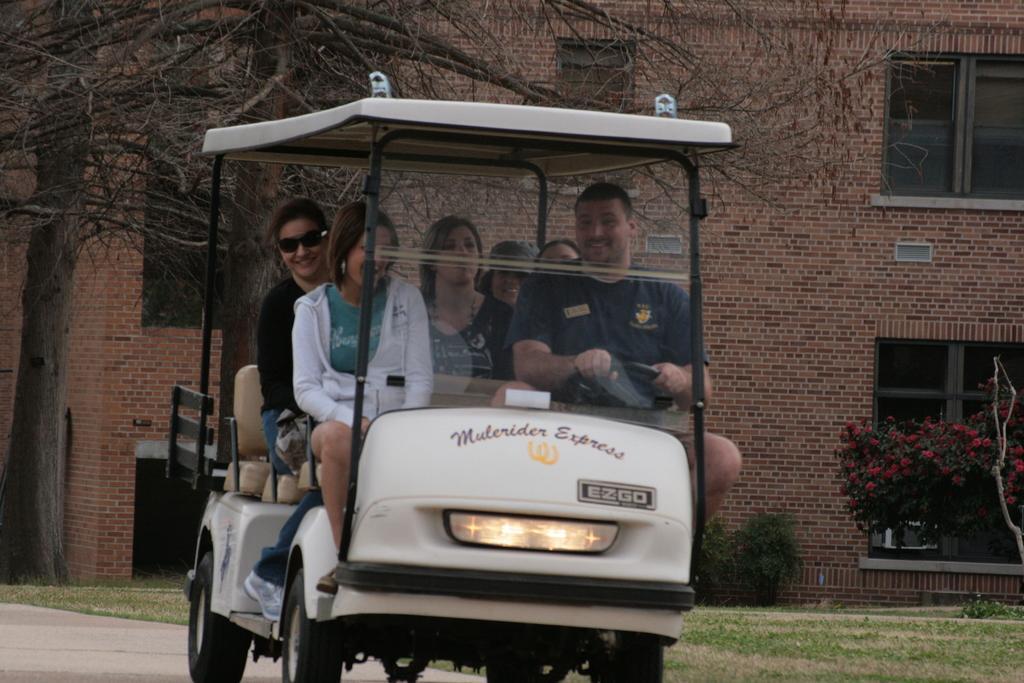Can you describe this image briefly? On the road there is a vehicle. There are six people sitting in this vehicle. A man with blue t-shirt is driving a vehicle. Beside him there is a lady with white jacket. And at the back there are four people. In the right side background there is a building with window. And to the bottom right there is a grass and a tree. To the left side there is a tree. 